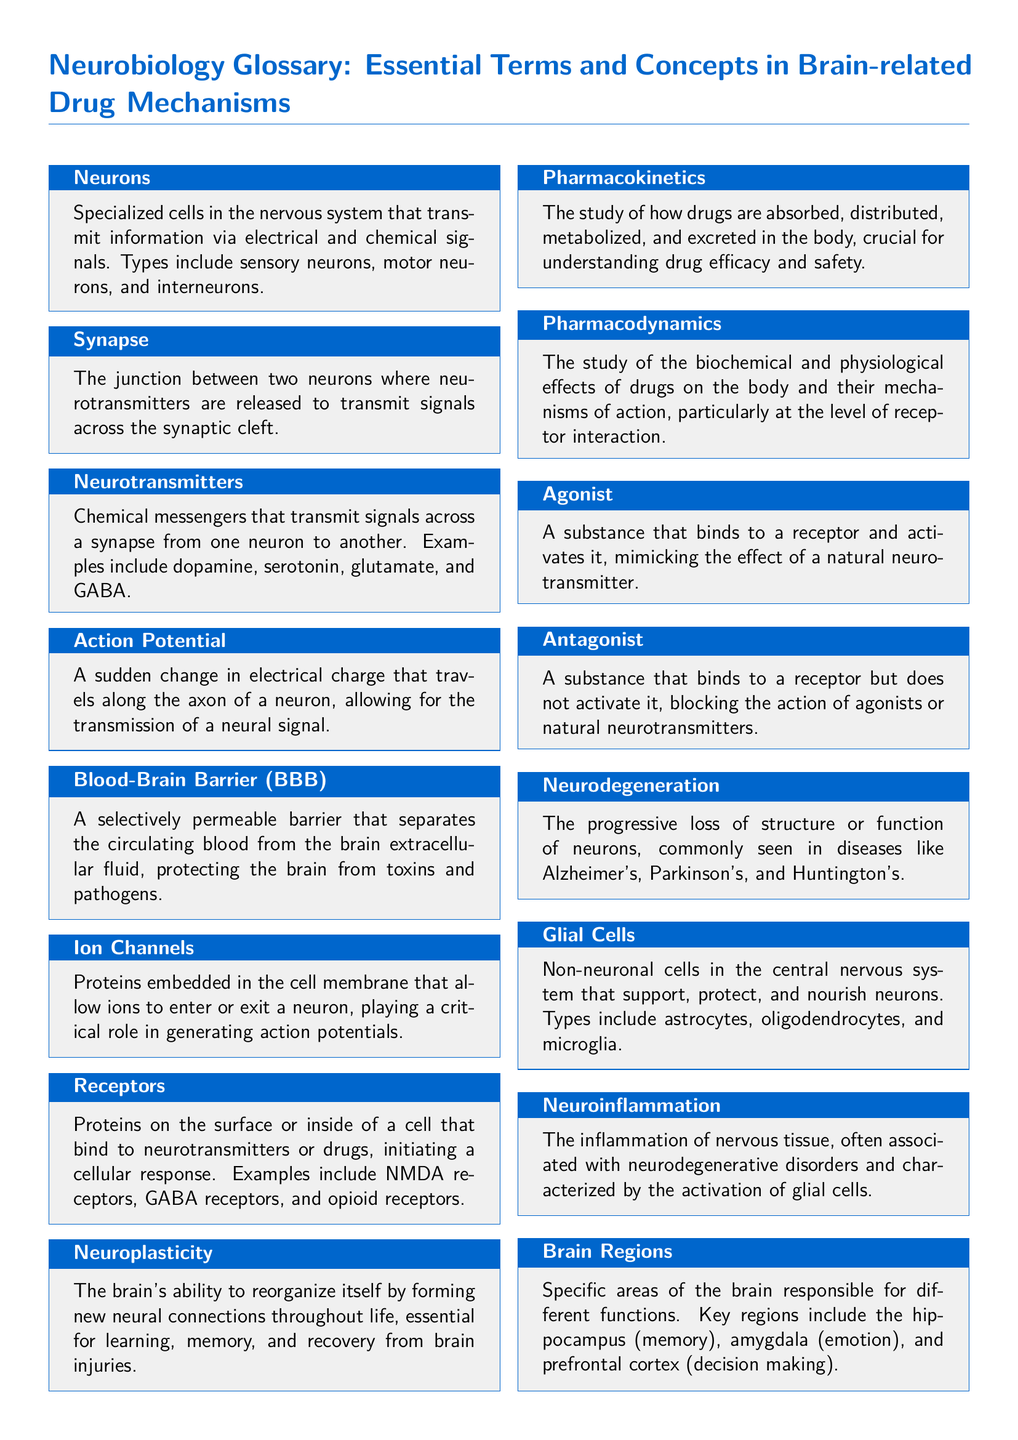What are neurons? Neurons are specialized cells in the nervous system that transmit information via electrical and chemical signals.
Answer: Specialized cells What is the function of neurotransmitters? Neurotransmitters are chemical messengers that transmit signals across a synapse from one neuron to another.
Answer: Transmit signals What does blood-brain barrier stand for? Blood-brain barrier is a selectively permeable barrier that separates the circulating blood from the brain extracellular fluid.
Answer: BBB What are glial cells? Glial cells are non-neuronal cells in the central nervous system that support, protect, and nourish neurons.
Answer: Non-neuronal cells What is neuroplasticity? Neuroplasticity is the brain's ability to reorganize itself by forming new neural connections throughout life.
Answer: Brain's ability to reorganize What do agonists do? Agonists bind to a receptor and activate it, mimicking the effect of a natural neurotransmitter.
Answer: Activate receptors What is the primary focus of pharmacodynamics? Pharmacodynamics focuses on the biochemical and physiological effects of drugs on the body and their mechanisms of action.
Answer: Drug effects Which brain region is responsible for memory? The hippocampus is the brain region responsible for memory.
Answer: Hippocampus What characterizes neuroinflammation? Neuroinflammation is characterized by the activation of glial cells and is often associated with neurodegenerative disorders.
Answer: Activation of glial cells 